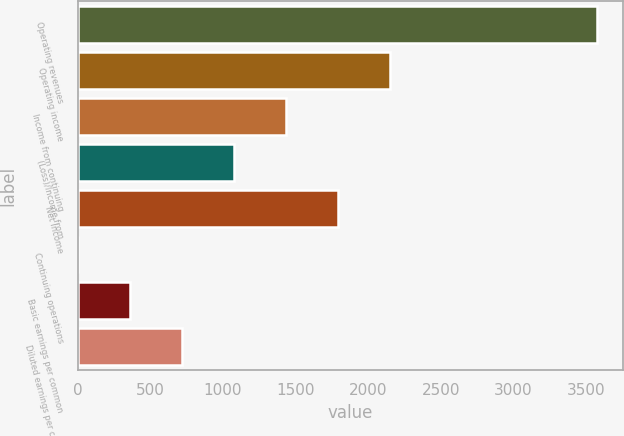<chart> <loc_0><loc_0><loc_500><loc_500><bar_chart><fcel>Operating revenues<fcel>Operating income<fcel>Income from continuing<fcel>(Loss)/Income from<fcel>Net income<fcel>Continuing operations<fcel>Basic earnings per common<fcel>Diluted earnings per common<nl><fcel>3579<fcel>2147.88<fcel>1432.3<fcel>1074.51<fcel>1790.09<fcel>1.14<fcel>358.93<fcel>716.72<nl></chart> 